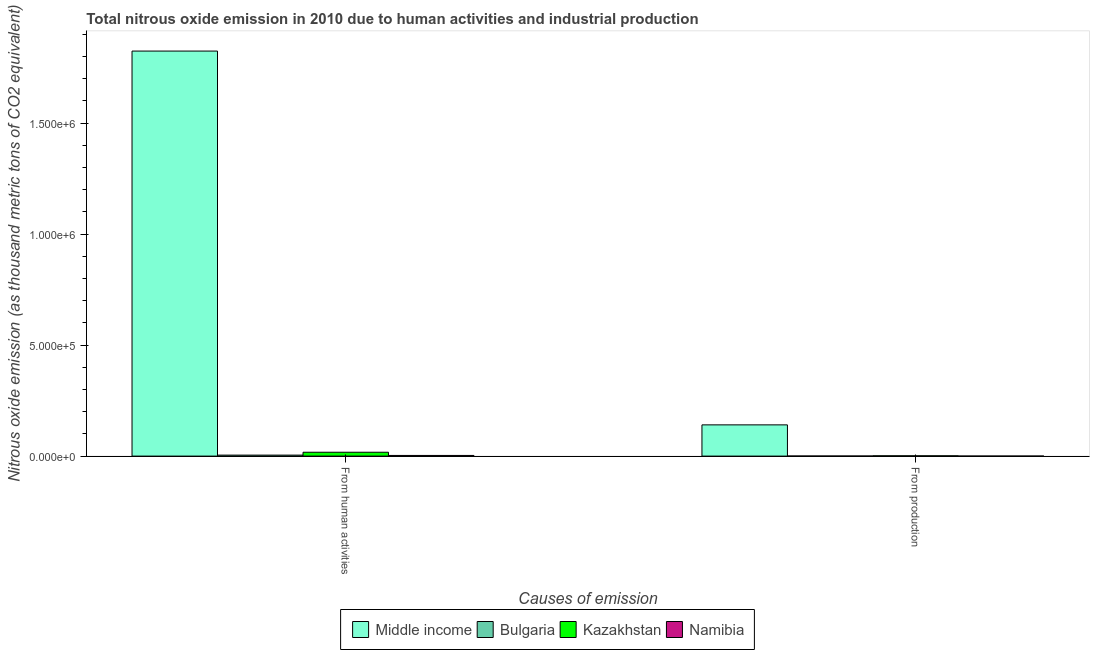How many different coloured bars are there?
Your answer should be very brief. 4. Are the number of bars per tick equal to the number of legend labels?
Give a very brief answer. Yes. Are the number of bars on each tick of the X-axis equal?
Your response must be concise. Yes. What is the label of the 1st group of bars from the left?
Ensure brevity in your answer.  From human activities. What is the amount of emissions from human activities in Namibia?
Provide a short and direct response. 2982.6. Across all countries, what is the maximum amount of emissions from human activities?
Offer a very short reply. 1.82e+06. Across all countries, what is the minimum amount of emissions from human activities?
Keep it short and to the point. 2982.6. In which country was the amount of emissions from human activities minimum?
Give a very brief answer. Namibia. What is the total amount of emissions generated from industries in the graph?
Offer a terse response. 1.43e+05. What is the difference between the amount of emissions from human activities in Namibia and that in Bulgaria?
Keep it short and to the point. -1496.6. What is the difference between the amount of emissions from human activities in Bulgaria and the amount of emissions generated from industries in Kazakhstan?
Your answer should be very brief. 3122.3. What is the average amount of emissions from human activities per country?
Provide a short and direct response. 4.62e+05. What is the difference between the amount of emissions from human activities and amount of emissions generated from industries in Bulgaria?
Your answer should be very brief. 4193.8. In how many countries, is the amount of emissions from human activities greater than 1600000 thousand metric tons?
Your answer should be compact. 1. What is the ratio of the amount of emissions generated from industries in Namibia to that in Kazakhstan?
Offer a very short reply. 0.1. What does the 4th bar from the right in From production represents?
Provide a succinct answer. Middle income. Are all the bars in the graph horizontal?
Provide a succinct answer. No. What is the difference between two consecutive major ticks on the Y-axis?
Offer a terse response. 5.00e+05. Are the values on the major ticks of Y-axis written in scientific E-notation?
Provide a short and direct response. Yes. What is the title of the graph?
Your answer should be compact. Total nitrous oxide emission in 2010 due to human activities and industrial production. Does "Sao Tome and Principe" appear as one of the legend labels in the graph?
Make the answer very short. No. What is the label or title of the X-axis?
Ensure brevity in your answer.  Causes of emission. What is the label or title of the Y-axis?
Your answer should be compact. Nitrous oxide emission (as thousand metric tons of CO2 equivalent). What is the Nitrous oxide emission (as thousand metric tons of CO2 equivalent) of Middle income in From human activities?
Offer a very short reply. 1.82e+06. What is the Nitrous oxide emission (as thousand metric tons of CO2 equivalent) in Bulgaria in From human activities?
Ensure brevity in your answer.  4479.2. What is the Nitrous oxide emission (as thousand metric tons of CO2 equivalent) in Kazakhstan in From human activities?
Make the answer very short. 1.75e+04. What is the Nitrous oxide emission (as thousand metric tons of CO2 equivalent) of Namibia in From human activities?
Offer a very short reply. 2982.6. What is the Nitrous oxide emission (as thousand metric tons of CO2 equivalent) of Middle income in From production?
Offer a very short reply. 1.41e+05. What is the Nitrous oxide emission (as thousand metric tons of CO2 equivalent) of Bulgaria in From production?
Provide a short and direct response. 285.4. What is the Nitrous oxide emission (as thousand metric tons of CO2 equivalent) of Kazakhstan in From production?
Offer a terse response. 1356.9. What is the Nitrous oxide emission (as thousand metric tons of CO2 equivalent) in Namibia in From production?
Provide a short and direct response. 134.4. Across all Causes of emission, what is the maximum Nitrous oxide emission (as thousand metric tons of CO2 equivalent) in Middle income?
Your answer should be compact. 1.82e+06. Across all Causes of emission, what is the maximum Nitrous oxide emission (as thousand metric tons of CO2 equivalent) of Bulgaria?
Provide a short and direct response. 4479.2. Across all Causes of emission, what is the maximum Nitrous oxide emission (as thousand metric tons of CO2 equivalent) in Kazakhstan?
Keep it short and to the point. 1.75e+04. Across all Causes of emission, what is the maximum Nitrous oxide emission (as thousand metric tons of CO2 equivalent) in Namibia?
Provide a short and direct response. 2982.6. Across all Causes of emission, what is the minimum Nitrous oxide emission (as thousand metric tons of CO2 equivalent) of Middle income?
Your answer should be compact. 1.41e+05. Across all Causes of emission, what is the minimum Nitrous oxide emission (as thousand metric tons of CO2 equivalent) of Bulgaria?
Your answer should be very brief. 285.4. Across all Causes of emission, what is the minimum Nitrous oxide emission (as thousand metric tons of CO2 equivalent) of Kazakhstan?
Make the answer very short. 1356.9. Across all Causes of emission, what is the minimum Nitrous oxide emission (as thousand metric tons of CO2 equivalent) in Namibia?
Provide a short and direct response. 134.4. What is the total Nitrous oxide emission (as thousand metric tons of CO2 equivalent) of Middle income in the graph?
Give a very brief answer. 1.97e+06. What is the total Nitrous oxide emission (as thousand metric tons of CO2 equivalent) in Bulgaria in the graph?
Offer a terse response. 4764.6. What is the total Nitrous oxide emission (as thousand metric tons of CO2 equivalent) in Kazakhstan in the graph?
Your response must be concise. 1.88e+04. What is the total Nitrous oxide emission (as thousand metric tons of CO2 equivalent) in Namibia in the graph?
Provide a short and direct response. 3117. What is the difference between the Nitrous oxide emission (as thousand metric tons of CO2 equivalent) of Middle income in From human activities and that in From production?
Provide a short and direct response. 1.68e+06. What is the difference between the Nitrous oxide emission (as thousand metric tons of CO2 equivalent) in Bulgaria in From human activities and that in From production?
Give a very brief answer. 4193.8. What is the difference between the Nitrous oxide emission (as thousand metric tons of CO2 equivalent) in Kazakhstan in From human activities and that in From production?
Offer a terse response. 1.61e+04. What is the difference between the Nitrous oxide emission (as thousand metric tons of CO2 equivalent) in Namibia in From human activities and that in From production?
Your response must be concise. 2848.2. What is the difference between the Nitrous oxide emission (as thousand metric tons of CO2 equivalent) in Middle income in From human activities and the Nitrous oxide emission (as thousand metric tons of CO2 equivalent) in Bulgaria in From production?
Your response must be concise. 1.82e+06. What is the difference between the Nitrous oxide emission (as thousand metric tons of CO2 equivalent) in Middle income in From human activities and the Nitrous oxide emission (as thousand metric tons of CO2 equivalent) in Kazakhstan in From production?
Ensure brevity in your answer.  1.82e+06. What is the difference between the Nitrous oxide emission (as thousand metric tons of CO2 equivalent) of Middle income in From human activities and the Nitrous oxide emission (as thousand metric tons of CO2 equivalent) of Namibia in From production?
Ensure brevity in your answer.  1.82e+06. What is the difference between the Nitrous oxide emission (as thousand metric tons of CO2 equivalent) of Bulgaria in From human activities and the Nitrous oxide emission (as thousand metric tons of CO2 equivalent) of Kazakhstan in From production?
Make the answer very short. 3122.3. What is the difference between the Nitrous oxide emission (as thousand metric tons of CO2 equivalent) in Bulgaria in From human activities and the Nitrous oxide emission (as thousand metric tons of CO2 equivalent) in Namibia in From production?
Offer a terse response. 4344.8. What is the difference between the Nitrous oxide emission (as thousand metric tons of CO2 equivalent) in Kazakhstan in From human activities and the Nitrous oxide emission (as thousand metric tons of CO2 equivalent) in Namibia in From production?
Keep it short and to the point. 1.73e+04. What is the average Nitrous oxide emission (as thousand metric tons of CO2 equivalent) in Middle income per Causes of emission?
Make the answer very short. 9.83e+05. What is the average Nitrous oxide emission (as thousand metric tons of CO2 equivalent) of Bulgaria per Causes of emission?
Keep it short and to the point. 2382.3. What is the average Nitrous oxide emission (as thousand metric tons of CO2 equivalent) of Kazakhstan per Causes of emission?
Your response must be concise. 9405.5. What is the average Nitrous oxide emission (as thousand metric tons of CO2 equivalent) of Namibia per Causes of emission?
Provide a succinct answer. 1558.5. What is the difference between the Nitrous oxide emission (as thousand metric tons of CO2 equivalent) in Middle income and Nitrous oxide emission (as thousand metric tons of CO2 equivalent) in Bulgaria in From human activities?
Keep it short and to the point. 1.82e+06. What is the difference between the Nitrous oxide emission (as thousand metric tons of CO2 equivalent) of Middle income and Nitrous oxide emission (as thousand metric tons of CO2 equivalent) of Kazakhstan in From human activities?
Provide a short and direct response. 1.81e+06. What is the difference between the Nitrous oxide emission (as thousand metric tons of CO2 equivalent) of Middle income and Nitrous oxide emission (as thousand metric tons of CO2 equivalent) of Namibia in From human activities?
Provide a short and direct response. 1.82e+06. What is the difference between the Nitrous oxide emission (as thousand metric tons of CO2 equivalent) in Bulgaria and Nitrous oxide emission (as thousand metric tons of CO2 equivalent) in Kazakhstan in From human activities?
Give a very brief answer. -1.30e+04. What is the difference between the Nitrous oxide emission (as thousand metric tons of CO2 equivalent) in Bulgaria and Nitrous oxide emission (as thousand metric tons of CO2 equivalent) in Namibia in From human activities?
Ensure brevity in your answer.  1496.6. What is the difference between the Nitrous oxide emission (as thousand metric tons of CO2 equivalent) of Kazakhstan and Nitrous oxide emission (as thousand metric tons of CO2 equivalent) of Namibia in From human activities?
Give a very brief answer. 1.45e+04. What is the difference between the Nitrous oxide emission (as thousand metric tons of CO2 equivalent) of Middle income and Nitrous oxide emission (as thousand metric tons of CO2 equivalent) of Bulgaria in From production?
Your response must be concise. 1.40e+05. What is the difference between the Nitrous oxide emission (as thousand metric tons of CO2 equivalent) of Middle income and Nitrous oxide emission (as thousand metric tons of CO2 equivalent) of Kazakhstan in From production?
Your response must be concise. 1.39e+05. What is the difference between the Nitrous oxide emission (as thousand metric tons of CO2 equivalent) in Middle income and Nitrous oxide emission (as thousand metric tons of CO2 equivalent) in Namibia in From production?
Offer a terse response. 1.41e+05. What is the difference between the Nitrous oxide emission (as thousand metric tons of CO2 equivalent) in Bulgaria and Nitrous oxide emission (as thousand metric tons of CO2 equivalent) in Kazakhstan in From production?
Give a very brief answer. -1071.5. What is the difference between the Nitrous oxide emission (as thousand metric tons of CO2 equivalent) in Bulgaria and Nitrous oxide emission (as thousand metric tons of CO2 equivalent) in Namibia in From production?
Your answer should be very brief. 151. What is the difference between the Nitrous oxide emission (as thousand metric tons of CO2 equivalent) of Kazakhstan and Nitrous oxide emission (as thousand metric tons of CO2 equivalent) of Namibia in From production?
Provide a short and direct response. 1222.5. What is the ratio of the Nitrous oxide emission (as thousand metric tons of CO2 equivalent) in Middle income in From human activities to that in From production?
Provide a short and direct response. 12.96. What is the ratio of the Nitrous oxide emission (as thousand metric tons of CO2 equivalent) of Bulgaria in From human activities to that in From production?
Keep it short and to the point. 15.69. What is the ratio of the Nitrous oxide emission (as thousand metric tons of CO2 equivalent) in Kazakhstan in From human activities to that in From production?
Give a very brief answer. 12.86. What is the ratio of the Nitrous oxide emission (as thousand metric tons of CO2 equivalent) in Namibia in From human activities to that in From production?
Your answer should be very brief. 22.19. What is the difference between the highest and the second highest Nitrous oxide emission (as thousand metric tons of CO2 equivalent) in Middle income?
Keep it short and to the point. 1.68e+06. What is the difference between the highest and the second highest Nitrous oxide emission (as thousand metric tons of CO2 equivalent) of Bulgaria?
Your answer should be compact. 4193.8. What is the difference between the highest and the second highest Nitrous oxide emission (as thousand metric tons of CO2 equivalent) in Kazakhstan?
Keep it short and to the point. 1.61e+04. What is the difference between the highest and the second highest Nitrous oxide emission (as thousand metric tons of CO2 equivalent) in Namibia?
Offer a terse response. 2848.2. What is the difference between the highest and the lowest Nitrous oxide emission (as thousand metric tons of CO2 equivalent) of Middle income?
Offer a terse response. 1.68e+06. What is the difference between the highest and the lowest Nitrous oxide emission (as thousand metric tons of CO2 equivalent) in Bulgaria?
Give a very brief answer. 4193.8. What is the difference between the highest and the lowest Nitrous oxide emission (as thousand metric tons of CO2 equivalent) of Kazakhstan?
Make the answer very short. 1.61e+04. What is the difference between the highest and the lowest Nitrous oxide emission (as thousand metric tons of CO2 equivalent) of Namibia?
Keep it short and to the point. 2848.2. 